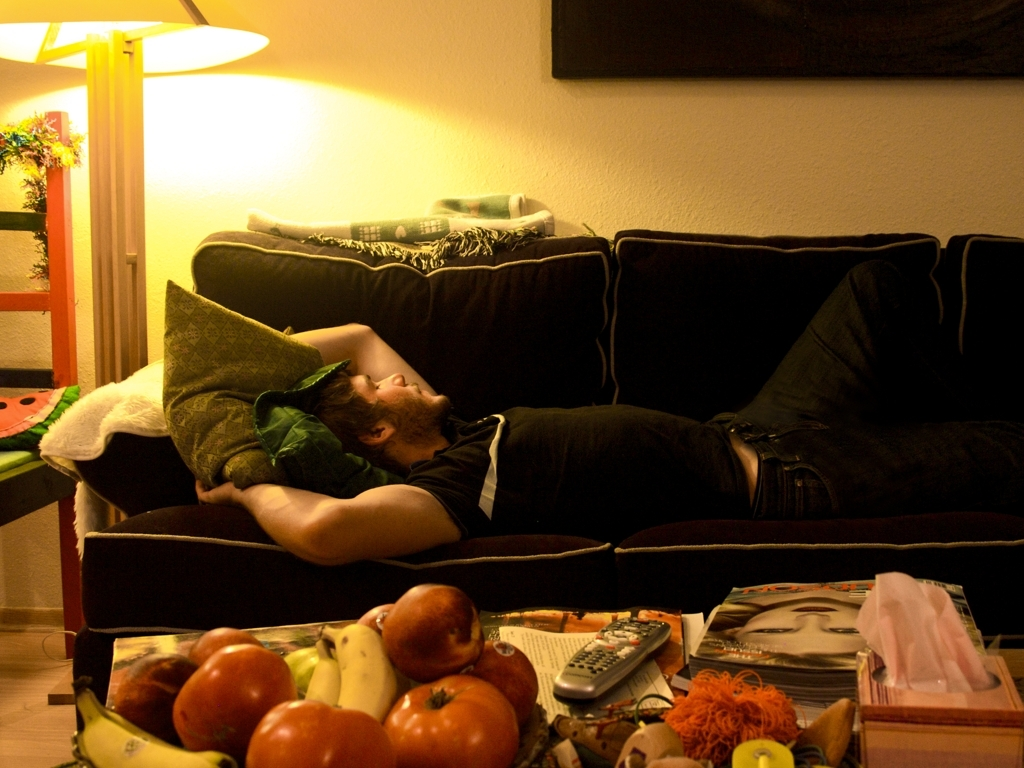What does the assortment of items on the table indicate about the person or the environment? The eclectic mix of healthy fruits, reading material, and entertainment options like the remote control and a toy suggest that the person values both relaxation and engagement, reflecting a balance between leisure and activity in their lifestyle. 